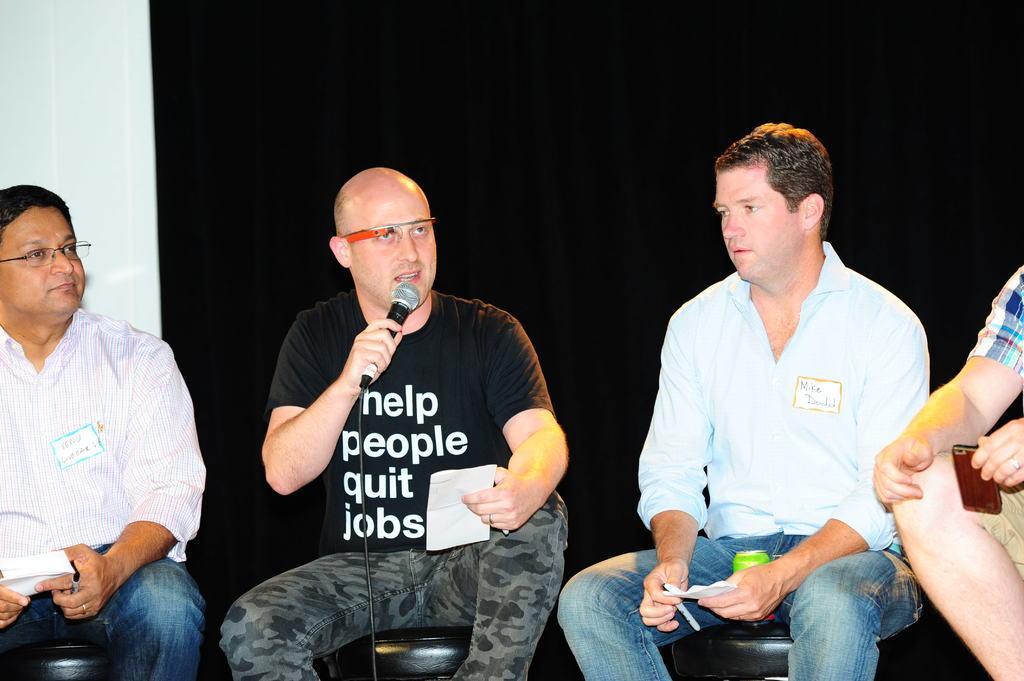Can you describe this image briefly? In this picture there are four persons, one person who is holding the mice in the hands is explaining about something towards facing the forward direction there are three people who are sitting beside the men are holding papers rather than a person who is holding a mobile. 